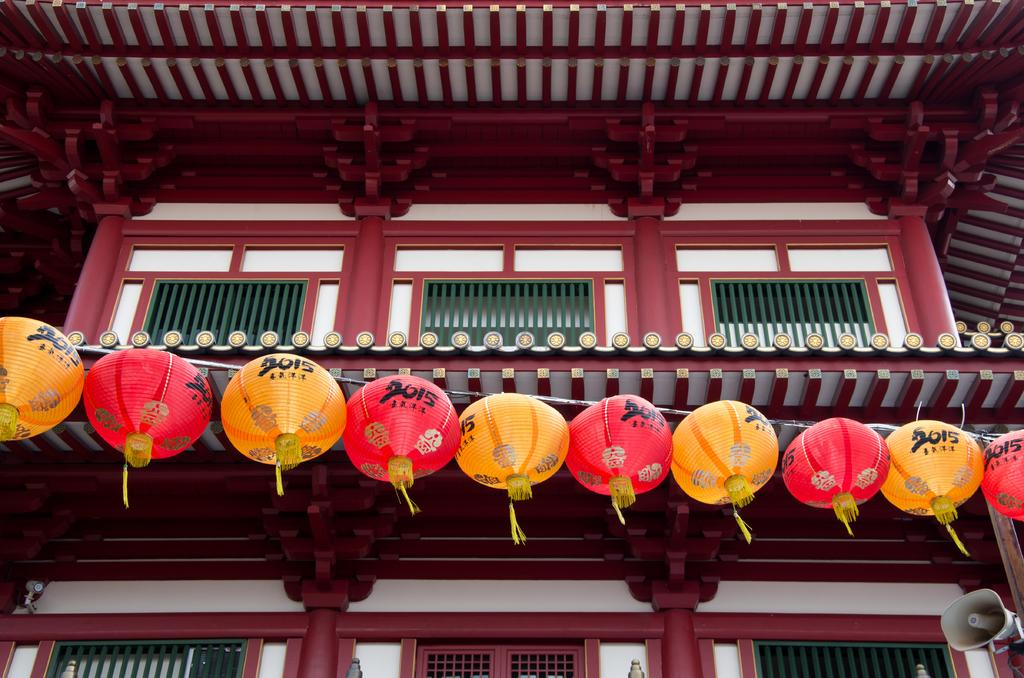<image>
Present a compact description of the photo's key features. A line of red and yellow paper lanterns with 2015 written on them are hung on a building. 